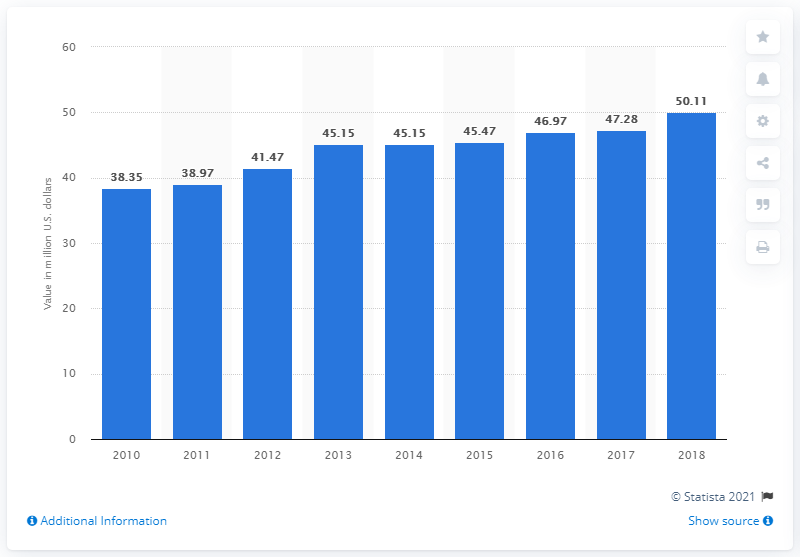Highlight a few significant elements in this photo. In 2018, the manufacturing sector contributed approximately 50.11 dollars to Saint Lucia's Gross Domestic Product. In 2018, the manufacturing sector added $47.28 million in value to Saint Lucia's Gross Domestic Product. 